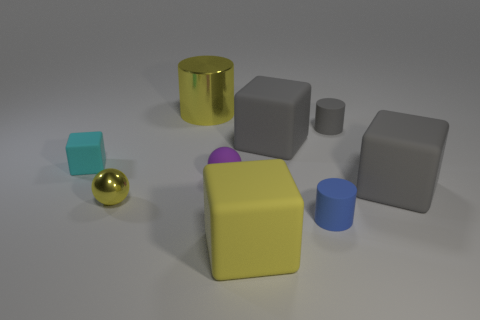Are there any other metallic objects that have the same color as the tiny metal thing?
Give a very brief answer. Yes. What is the shape of the rubber object that is both to the left of the tiny gray matte cylinder and behind the cyan rubber thing?
Make the answer very short. Cube. The metallic object in front of the big gray rubber thing that is to the right of the tiny blue thing is what shape?
Your answer should be compact. Sphere. Is the shape of the tiny gray matte object the same as the tiny yellow metallic thing?
Provide a short and direct response. No. What material is the small sphere that is the same color as the large metallic object?
Provide a short and direct response. Metal. Is the color of the large shiny cylinder the same as the tiny cube?
Provide a short and direct response. No. What number of small purple things are in front of the large gray matte block on the left side of the large gray rubber object right of the blue matte object?
Your answer should be compact. 1. What is the shape of the big yellow object that is the same material as the small blue cylinder?
Your answer should be very brief. Cube. What is the block in front of the yellow metallic object in front of the big gray matte object that is behind the small matte cube made of?
Your response must be concise. Rubber. What number of objects are either tiny objects that are in front of the yellow shiny sphere or cyan blocks?
Offer a very short reply. 2. 